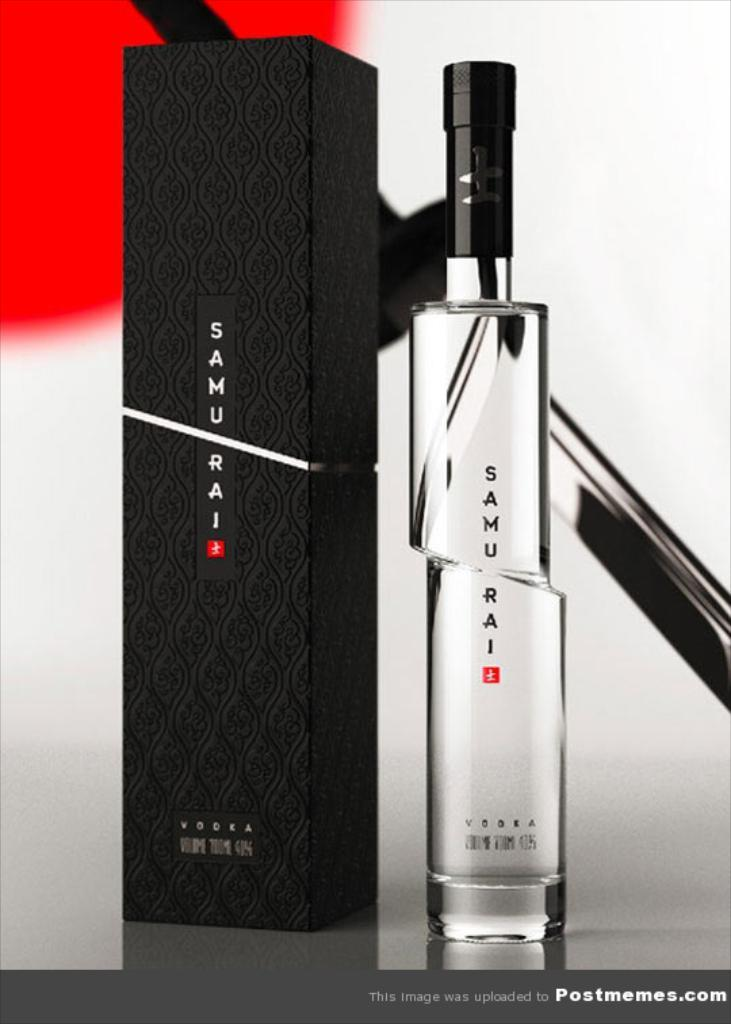<image>
Describe the image concisely. A bottle of Samu Rai Vodka is sitting next to a black box. 